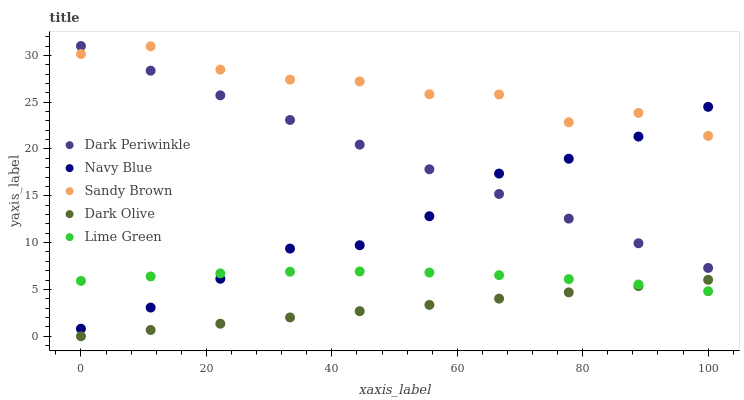Does Dark Olive have the minimum area under the curve?
Answer yes or no. Yes. Does Sandy Brown have the maximum area under the curve?
Answer yes or no. Yes. Does Sandy Brown have the minimum area under the curve?
Answer yes or no. No. Does Dark Olive have the maximum area under the curve?
Answer yes or no. No. Is Dark Olive the smoothest?
Answer yes or no. Yes. Is Sandy Brown the roughest?
Answer yes or no. Yes. Is Sandy Brown the smoothest?
Answer yes or no. No. Is Dark Olive the roughest?
Answer yes or no. No. Does Dark Olive have the lowest value?
Answer yes or no. Yes. Does Sandy Brown have the lowest value?
Answer yes or no. No. Does Dark Periwinkle have the highest value?
Answer yes or no. Yes. Does Sandy Brown have the highest value?
Answer yes or no. No. Is Lime Green less than Sandy Brown?
Answer yes or no. Yes. Is Dark Periwinkle greater than Lime Green?
Answer yes or no. Yes. Does Sandy Brown intersect Dark Periwinkle?
Answer yes or no. Yes. Is Sandy Brown less than Dark Periwinkle?
Answer yes or no. No. Is Sandy Brown greater than Dark Periwinkle?
Answer yes or no. No. Does Lime Green intersect Sandy Brown?
Answer yes or no. No. 